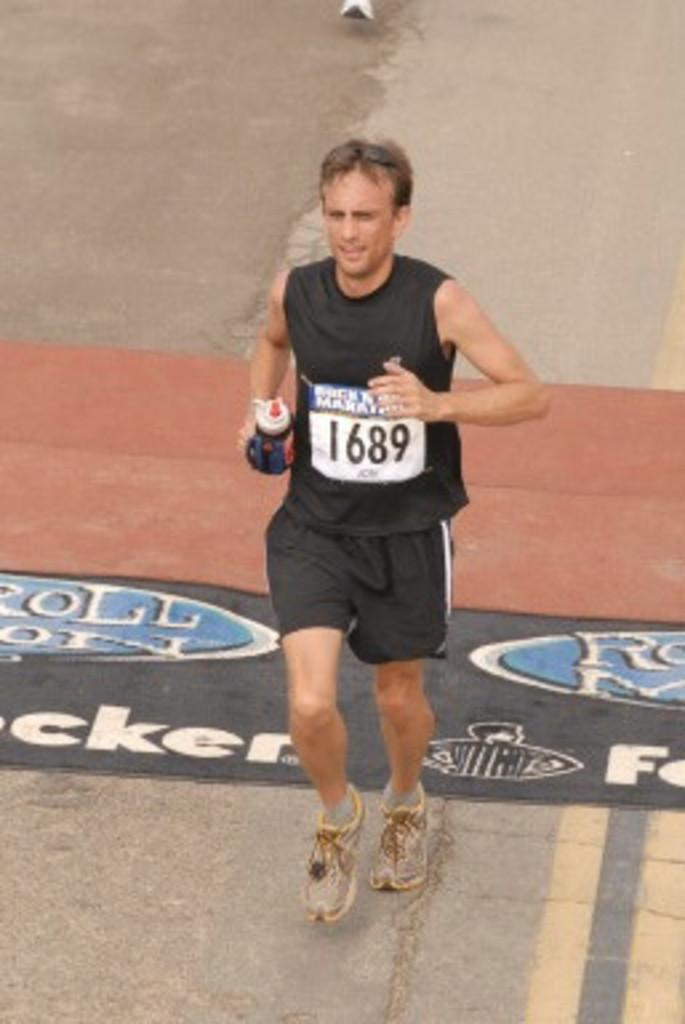Who is present in the image? There is a person in the image. What is the person wearing? The person is wearing a black dress. What is the person holding in the image? The person is holding a bottle. What is the person doing in the image? The person is running. What type of country music can be heard in the background of the image? There is no music or sound present in the image, so it is not possible to determine what type of music might be heard. 